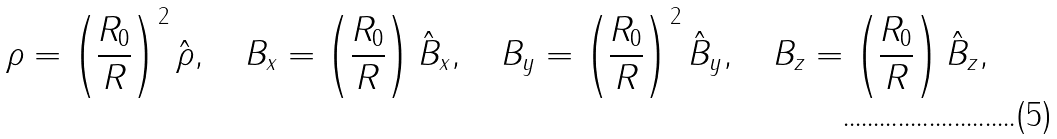<formula> <loc_0><loc_0><loc_500><loc_500>\rho = \left ( \frac { R _ { 0 } } { R } \right ) ^ { 2 } \hat { \rho } , \quad B _ { x } = \left ( \frac { R _ { 0 } } { R } \right ) \hat { B } _ { x } , \quad B _ { y } = \left ( \frac { R _ { 0 } } { R } \right ) ^ { 2 } \hat { B } _ { y } , \quad B _ { z } = \left ( \frac { R _ { 0 } } { R } \right ) \hat { B } _ { z } ,</formula> 